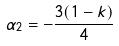<formula> <loc_0><loc_0><loc_500><loc_500>\alpha _ { 2 } = - \frac { 3 ( 1 - k ) } { 4 }</formula> 